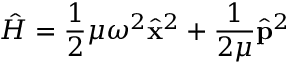Convert formula to latex. <formula><loc_0><loc_0><loc_500><loc_500>\hat { H } = \frac { 1 } { 2 } \mu \omega ^ { 2 } \hat { \mathbf x } ^ { 2 } + \frac { 1 } { 2 \mu } \hat { \mathbf p } ^ { 2 }</formula> 